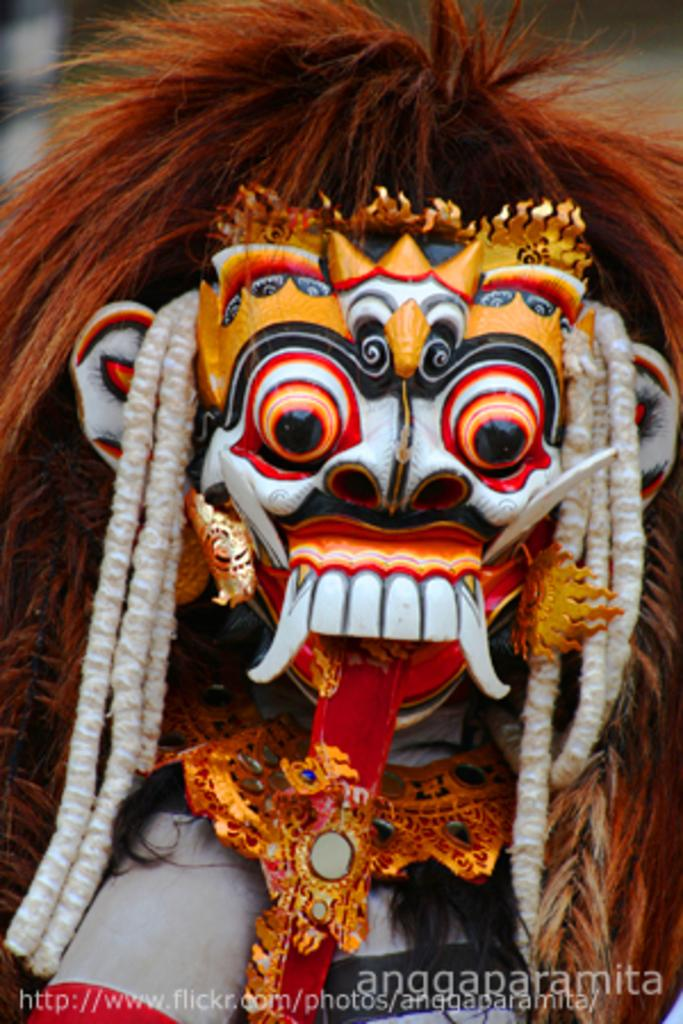What object is the main focus of the image? There is a face mask in the image. How would you describe the background of the image? The background of the image is blurred. Is there any additional information or branding present in the image? Yes, there is a watermark at the bottom of the image. What type of jam is being spread on the pin in the image? There is no jam or pin present in the image; it features a face mask and a blurred background. 